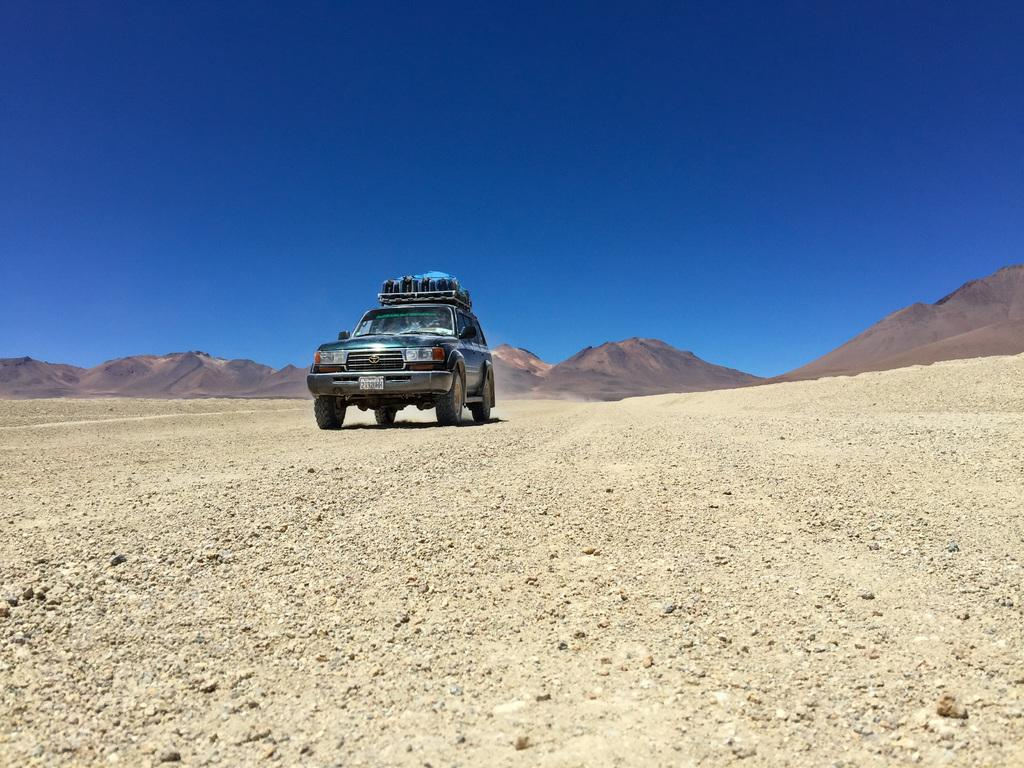What is the main subject in the center of the image? There is a vehicle in the center of the image. What can be seen in the background of the image? Hills and the sky are visible in the background of the image. How many balls are being copied in the image? There are no balls or copying activities present in the image. 